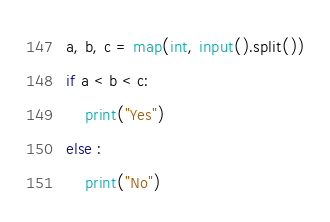Convert code to text. <code><loc_0><loc_0><loc_500><loc_500><_Python_>a, b, c = map(int, input().split())
if a < b < c:
    print("Yes")
else :
    print("No")
</code> 